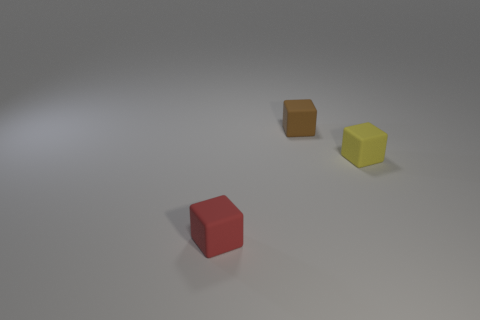What is the shape of the thing that is in front of the cube on the right side of the tiny object that is behind the small yellow matte thing? The item in question appears to be another cube, which is located closer to the foreground than the yellow cube, slightly to its right as viewed from the camera perspective. 